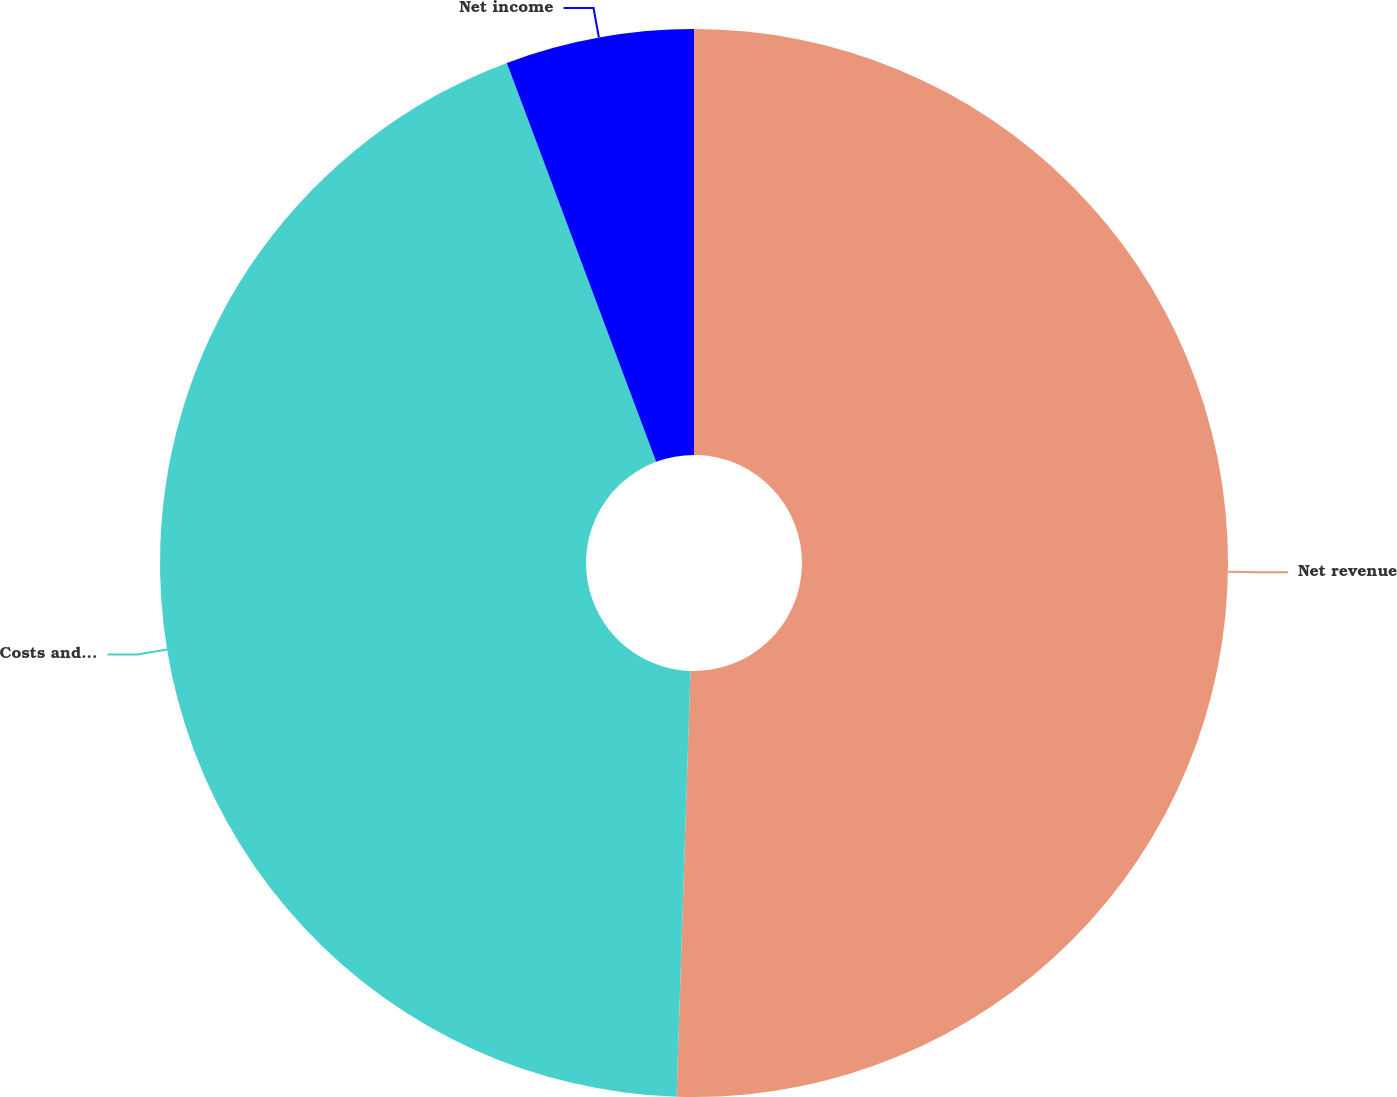Convert chart. <chart><loc_0><loc_0><loc_500><loc_500><pie_chart><fcel>Net revenue<fcel>Costs and expenses<fcel>Net income<nl><fcel>50.52%<fcel>43.78%<fcel>5.7%<nl></chart> 